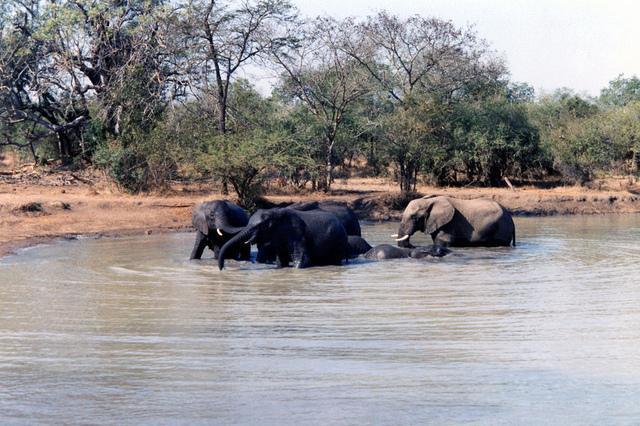What do the animals all have?
Choose the right answer from the provided options to respond to the question.
Options: Stingers, tusks, wings, gills. Tusks. Who has the last name that refers to what a group of these animals is called?
Select the accurate response from the four choices given to answer the question.
Options: Curtis pride, jim herd, anna camp, tim crowder. Jim herd. 